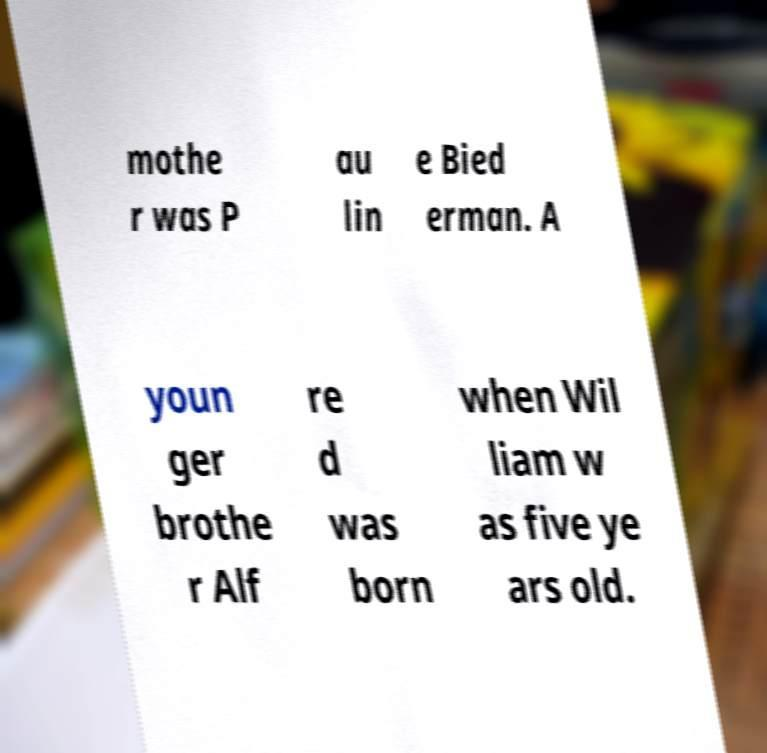For documentation purposes, I need the text within this image transcribed. Could you provide that? mothe r was P au lin e Bied erman. A youn ger brothe r Alf re d was born when Wil liam w as five ye ars old. 